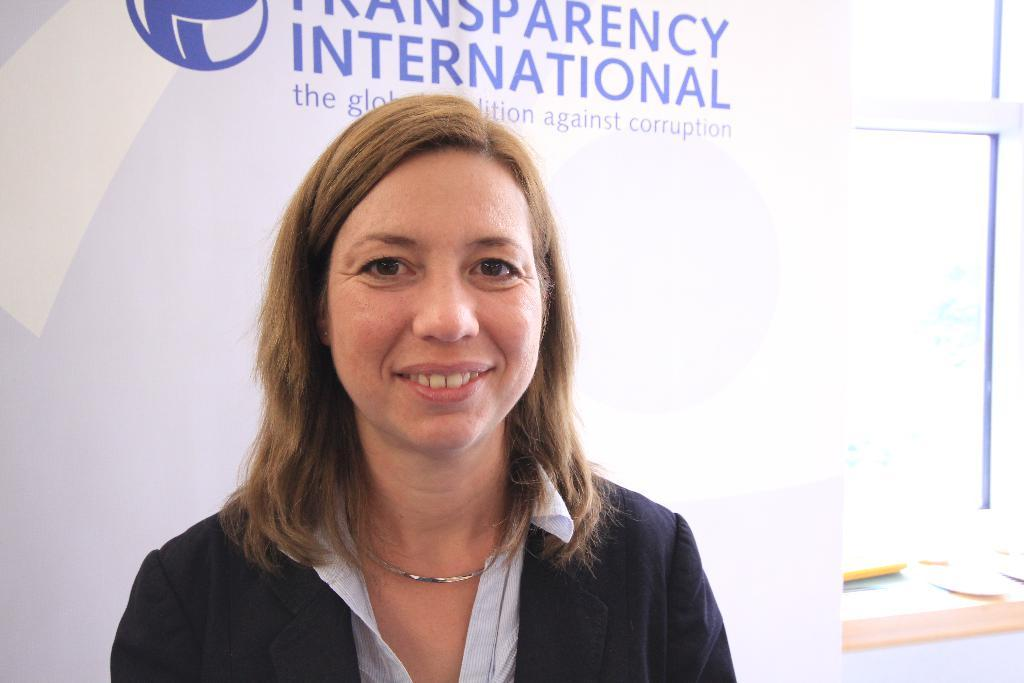What is the person in the image wearing? The person in the image is wearing a white and black color dress. What can be seen in the background of the image? There is a banner and a window in the background of the image. How many men are standing in the stream in the image? There is no stream or men present in the image. 